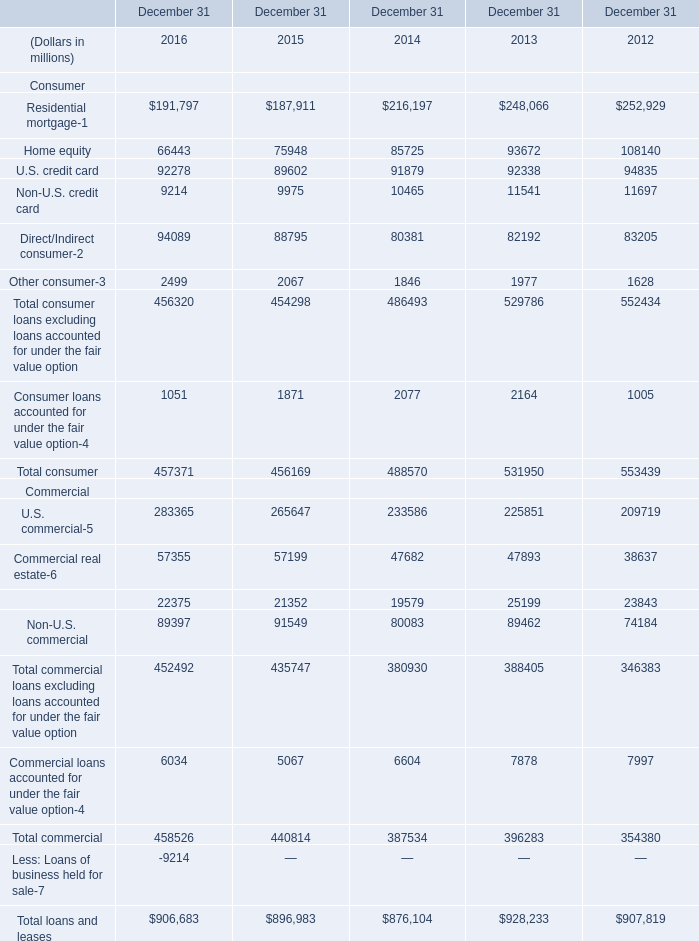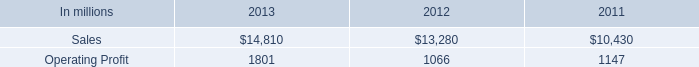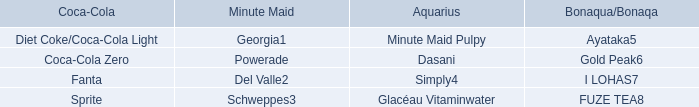What is the growing rate of Residential mortgage in table 0 in the year with the most Direct/Indirect consumer in table 0? 
Computations: ((191797 - 187911) / 187911)
Answer: 0.02068. What's the average of U.S. credit card in 2016, 2015, and 2014? (in millions) 
Computations: (((92278 + 89602) + 91879) / 3)
Answer: 91253.0. 